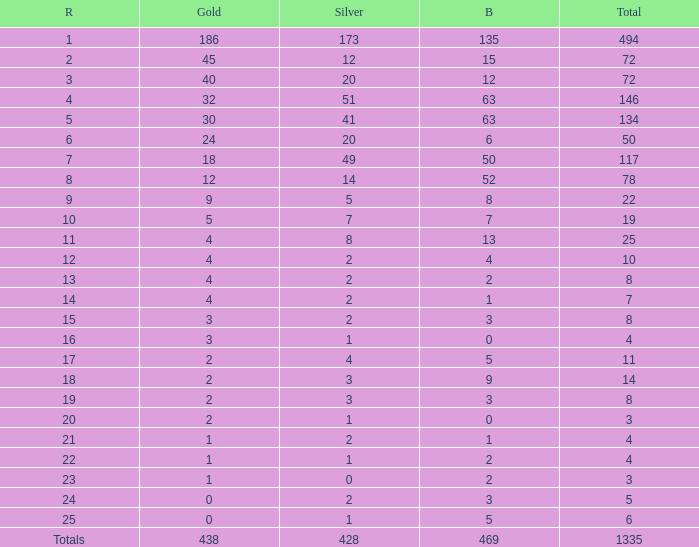What is the number of bronze medals when the total medals were 78 and there were less than 12 golds? None. 